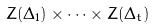Convert formula to latex. <formula><loc_0><loc_0><loc_500><loc_500>Z ( \Delta _ { 1 } ) \times \cdots \times Z ( \Delta _ { t } )</formula> 